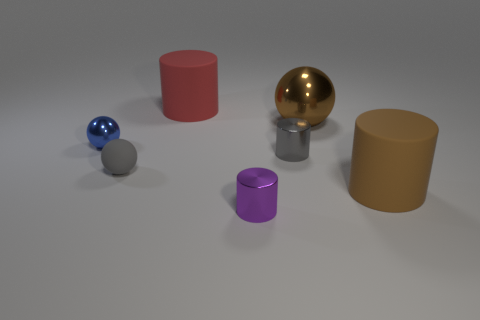There is a tiny matte ball that is to the right of the blue metallic thing; what number of tiny blue shiny things are in front of it?
Keep it short and to the point. 0. What is the material of the tiny gray object left of the tiny metal object in front of the large rubber object in front of the brown shiny sphere?
Your answer should be very brief. Rubber. What material is the thing that is to the right of the tiny purple object and on the left side of the big metal object?
Ensure brevity in your answer.  Metal. How many other large red rubber things have the same shape as the large red object?
Offer a very short reply. 0. What is the size of the brown thing that is behind the small gray object left of the red cylinder?
Provide a succinct answer. Large. There is a rubber cylinder that is behind the large brown sphere; is its color the same as the big cylinder that is to the right of the brown ball?
Provide a short and direct response. No. What number of large brown shiny spheres are in front of the small gray thing that is to the right of the large matte cylinder that is behind the matte sphere?
Offer a very short reply. 0. How many large matte things are both behind the small gray rubber object and right of the big red thing?
Provide a succinct answer. 0. Are there more brown things that are right of the red cylinder than big gray blocks?
Your answer should be very brief. Yes. What number of brown metallic spheres are the same size as the red cylinder?
Ensure brevity in your answer.  1. 